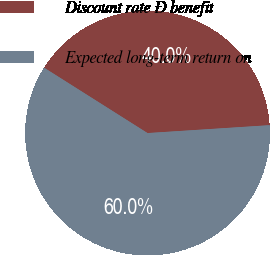<chart> <loc_0><loc_0><loc_500><loc_500><pie_chart><fcel>Discount rate Ð benefit<fcel>Expected long-term return on<nl><fcel>40.0%<fcel>60.0%<nl></chart> 